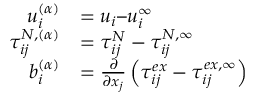<formula> <loc_0><loc_0><loc_500><loc_500>\begin{array} { r l } { u _ { i } ^ { ( \alpha ) } } & { = u _ { i } u _ { i } ^ { \infty } } \\ { \tau _ { i j } ^ { N , ( \alpha ) } } & { = \tau _ { i j } ^ { N } - \tau _ { i j } ^ { N , \infty } } \\ { b _ { i } ^ { ( \alpha ) } } & { = \frac { \partial } { \partial x _ { j } } \left ( \tau _ { i j } ^ { e x } - \tau _ { i j } ^ { e x , \infty } \right ) } \end{array}</formula> 